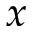<formula> <loc_0><loc_0><loc_500><loc_500>x</formula> 